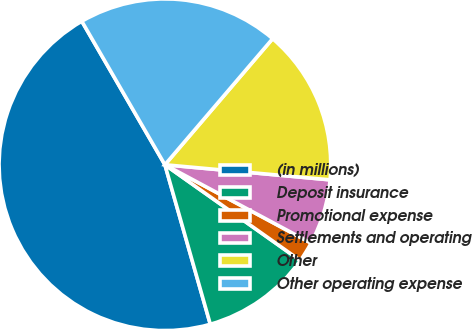<chart> <loc_0><loc_0><loc_500><loc_500><pie_chart><fcel>(in millions)<fcel>Deposit insurance<fcel>Promotional expense<fcel>Settlements and operating<fcel>Other<fcel>Other operating expense<nl><fcel>46.07%<fcel>10.79%<fcel>1.97%<fcel>6.38%<fcel>15.2%<fcel>19.61%<nl></chart> 